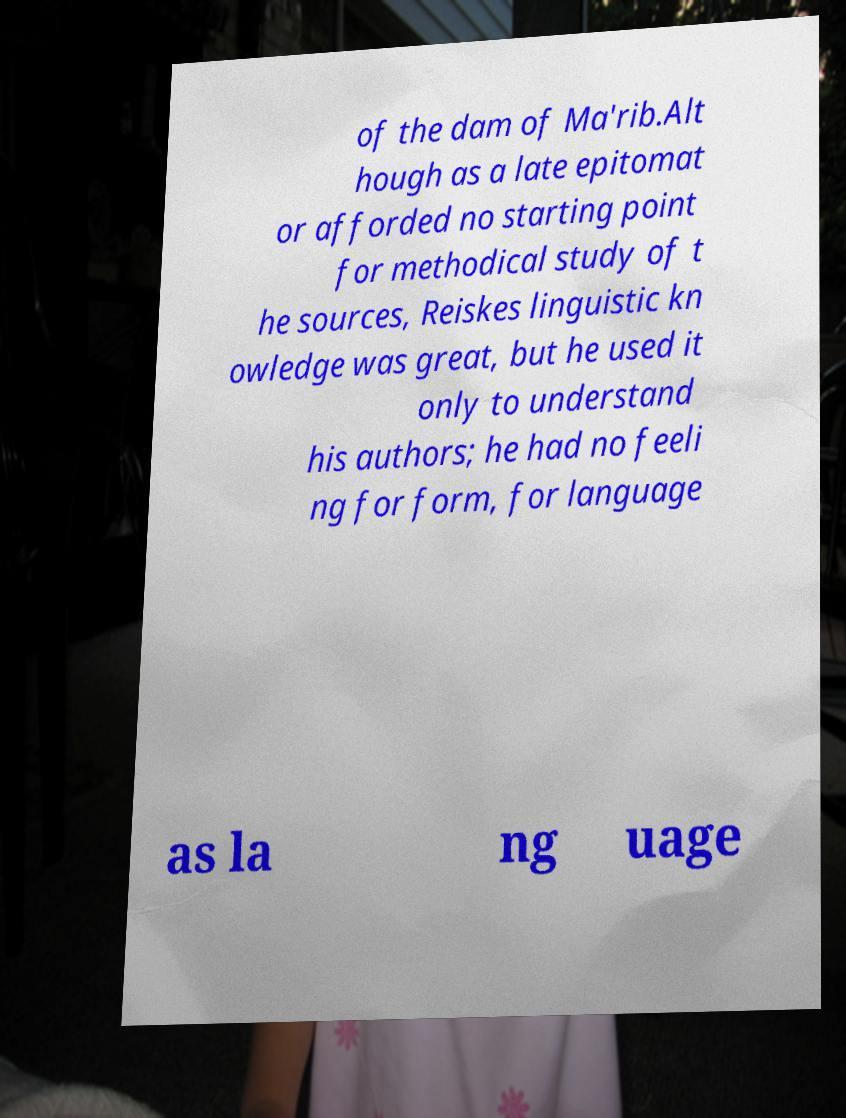Could you extract and type out the text from this image? of the dam of Ma'rib.Alt hough as a late epitomat or afforded no starting point for methodical study of t he sources, Reiskes linguistic kn owledge was great, but he used it only to understand his authors; he had no feeli ng for form, for language as la ng uage 